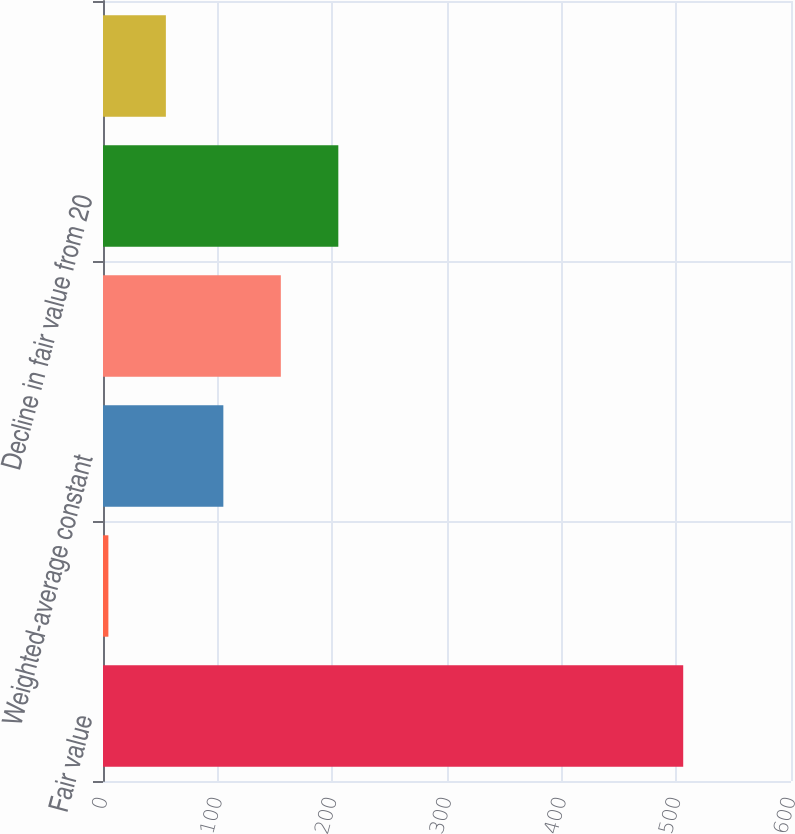Convert chart. <chart><loc_0><loc_0><loc_500><loc_500><bar_chart><fcel>Fair value<fcel>Weighted-average life (years)<fcel>Weighted-average constant<fcel>Decline in fair value from 10<fcel>Decline in fair value from 20<fcel>Effective discount rate<nl><fcel>506<fcel>4.7<fcel>104.96<fcel>155.09<fcel>205.22<fcel>54.83<nl></chart> 